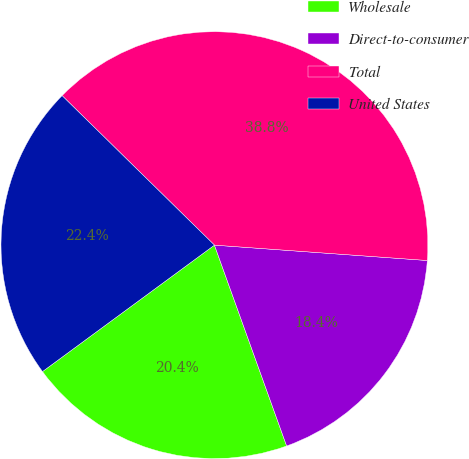Convert chart to OTSL. <chart><loc_0><loc_0><loc_500><loc_500><pie_chart><fcel>Wholesale<fcel>Direct-to-consumer<fcel>Total<fcel>United States<nl><fcel>20.4%<fcel>18.36%<fcel>38.8%<fcel>22.44%<nl></chart> 